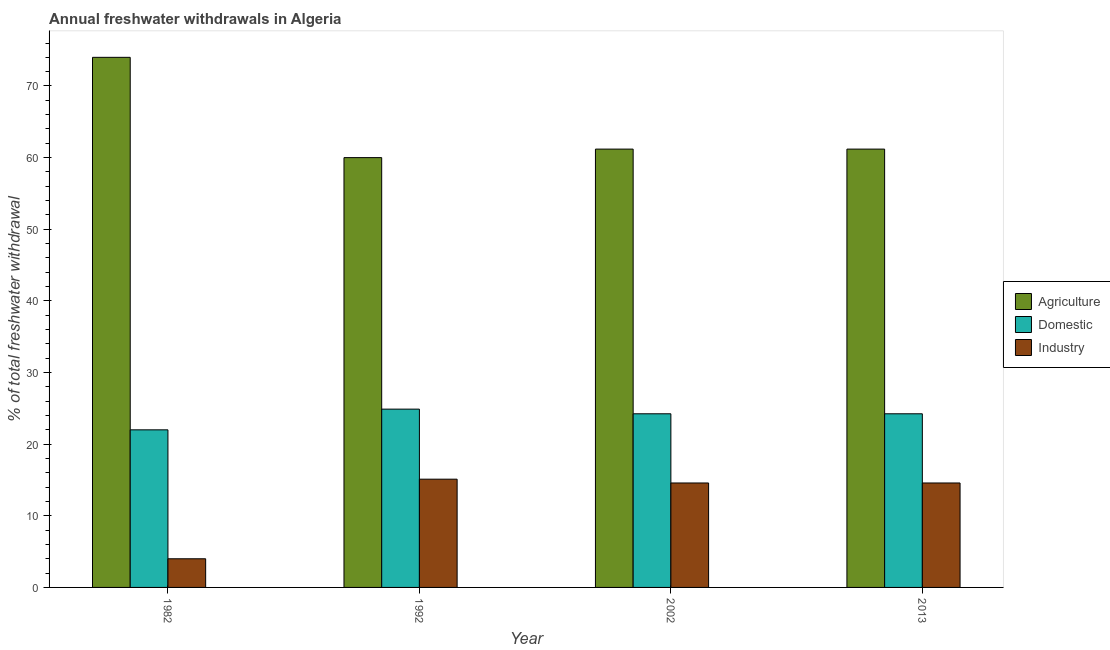How many different coloured bars are there?
Your answer should be very brief. 3. Are the number of bars per tick equal to the number of legend labels?
Your response must be concise. Yes. What is the label of the 4th group of bars from the left?
Make the answer very short. 2013. In how many cases, is the number of bars for a given year not equal to the number of legend labels?
Provide a short and direct response. 0. What is the percentage of freshwater withdrawal for domestic purposes in 2013?
Your response must be concise. 24.24. Across all years, what is the maximum percentage of freshwater withdrawal for industry?
Make the answer very short. 15.11. What is the total percentage of freshwater withdrawal for industry in the graph?
Your answer should be very brief. 48.27. What is the difference between the percentage of freshwater withdrawal for industry in 1982 and that in 2013?
Ensure brevity in your answer.  -10.58. What is the average percentage of freshwater withdrawal for agriculture per year?
Make the answer very short. 64.09. In the year 2002, what is the difference between the percentage of freshwater withdrawal for agriculture and percentage of freshwater withdrawal for domestic purposes?
Provide a short and direct response. 0. In how many years, is the percentage of freshwater withdrawal for industry greater than 70 %?
Offer a very short reply. 0. What is the ratio of the percentage of freshwater withdrawal for agriculture in 1982 to that in 2002?
Provide a short and direct response. 1.21. Is the difference between the percentage of freshwater withdrawal for agriculture in 1992 and 2013 greater than the difference between the percentage of freshwater withdrawal for industry in 1992 and 2013?
Offer a very short reply. No. What is the difference between the highest and the second highest percentage of freshwater withdrawal for agriculture?
Your answer should be very brief. 12.81. What is the difference between the highest and the lowest percentage of freshwater withdrawal for domestic purposes?
Ensure brevity in your answer.  2.89. Is the sum of the percentage of freshwater withdrawal for agriculture in 1992 and 2002 greater than the maximum percentage of freshwater withdrawal for industry across all years?
Give a very brief answer. Yes. What does the 3rd bar from the left in 2013 represents?
Offer a terse response. Industry. What does the 3rd bar from the right in 2002 represents?
Ensure brevity in your answer.  Agriculture. Is it the case that in every year, the sum of the percentage of freshwater withdrawal for agriculture and percentage of freshwater withdrawal for domestic purposes is greater than the percentage of freshwater withdrawal for industry?
Offer a terse response. Yes. How many bars are there?
Provide a short and direct response. 12. Are all the bars in the graph horizontal?
Keep it short and to the point. No. How many years are there in the graph?
Your response must be concise. 4. What is the difference between two consecutive major ticks on the Y-axis?
Your answer should be compact. 10. Are the values on the major ticks of Y-axis written in scientific E-notation?
Provide a short and direct response. No. Where does the legend appear in the graph?
Provide a succinct answer. Center right. How many legend labels are there?
Your response must be concise. 3. What is the title of the graph?
Offer a terse response. Annual freshwater withdrawals in Algeria. Does "Food" appear as one of the legend labels in the graph?
Make the answer very short. No. What is the label or title of the Y-axis?
Provide a succinct answer. % of total freshwater withdrawal. What is the % of total freshwater withdrawal of Agriculture in 1982?
Provide a succinct answer. 74. What is the % of total freshwater withdrawal of Agriculture in 1992?
Offer a very short reply. 60. What is the % of total freshwater withdrawal in Domestic in 1992?
Provide a succinct answer. 24.89. What is the % of total freshwater withdrawal in Industry in 1992?
Provide a succinct answer. 15.11. What is the % of total freshwater withdrawal in Agriculture in 2002?
Your response must be concise. 61.19. What is the % of total freshwater withdrawal in Domestic in 2002?
Your answer should be compact. 24.24. What is the % of total freshwater withdrawal of Industry in 2002?
Ensure brevity in your answer.  14.58. What is the % of total freshwater withdrawal in Agriculture in 2013?
Your answer should be compact. 61.19. What is the % of total freshwater withdrawal of Domestic in 2013?
Provide a succinct answer. 24.24. What is the % of total freshwater withdrawal in Industry in 2013?
Give a very brief answer. 14.58. Across all years, what is the maximum % of total freshwater withdrawal of Agriculture?
Offer a very short reply. 74. Across all years, what is the maximum % of total freshwater withdrawal in Domestic?
Your answer should be very brief. 24.89. Across all years, what is the maximum % of total freshwater withdrawal in Industry?
Your response must be concise. 15.11. Across all years, what is the minimum % of total freshwater withdrawal of Agriculture?
Keep it short and to the point. 60. Across all years, what is the minimum % of total freshwater withdrawal of Domestic?
Provide a succinct answer. 22. What is the total % of total freshwater withdrawal in Agriculture in the graph?
Provide a short and direct response. 256.38. What is the total % of total freshwater withdrawal in Domestic in the graph?
Give a very brief answer. 95.37. What is the total % of total freshwater withdrawal of Industry in the graph?
Offer a very short reply. 48.27. What is the difference between the % of total freshwater withdrawal in Domestic in 1982 and that in 1992?
Offer a very short reply. -2.89. What is the difference between the % of total freshwater withdrawal in Industry in 1982 and that in 1992?
Your response must be concise. -11.11. What is the difference between the % of total freshwater withdrawal of Agriculture in 1982 and that in 2002?
Offer a terse response. 12.81. What is the difference between the % of total freshwater withdrawal in Domestic in 1982 and that in 2002?
Make the answer very short. -2.24. What is the difference between the % of total freshwater withdrawal of Industry in 1982 and that in 2002?
Provide a short and direct response. -10.58. What is the difference between the % of total freshwater withdrawal in Agriculture in 1982 and that in 2013?
Provide a short and direct response. 12.81. What is the difference between the % of total freshwater withdrawal of Domestic in 1982 and that in 2013?
Your answer should be compact. -2.24. What is the difference between the % of total freshwater withdrawal in Industry in 1982 and that in 2013?
Offer a very short reply. -10.58. What is the difference between the % of total freshwater withdrawal in Agriculture in 1992 and that in 2002?
Provide a short and direct response. -1.19. What is the difference between the % of total freshwater withdrawal in Domestic in 1992 and that in 2002?
Your answer should be compact. 0.65. What is the difference between the % of total freshwater withdrawal of Industry in 1992 and that in 2002?
Offer a terse response. 0.53. What is the difference between the % of total freshwater withdrawal in Agriculture in 1992 and that in 2013?
Give a very brief answer. -1.19. What is the difference between the % of total freshwater withdrawal of Domestic in 1992 and that in 2013?
Provide a short and direct response. 0.65. What is the difference between the % of total freshwater withdrawal of Industry in 1992 and that in 2013?
Your answer should be very brief. 0.53. What is the difference between the % of total freshwater withdrawal in Agriculture in 2002 and that in 2013?
Your answer should be compact. 0. What is the difference between the % of total freshwater withdrawal of Domestic in 2002 and that in 2013?
Give a very brief answer. 0. What is the difference between the % of total freshwater withdrawal in Industry in 2002 and that in 2013?
Keep it short and to the point. 0. What is the difference between the % of total freshwater withdrawal in Agriculture in 1982 and the % of total freshwater withdrawal in Domestic in 1992?
Your response must be concise. 49.11. What is the difference between the % of total freshwater withdrawal in Agriculture in 1982 and the % of total freshwater withdrawal in Industry in 1992?
Offer a very short reply. 58.89. What is the difference between the % of total freshwater withdrawal of Domestic in 1982 and the % of total freshwater withdrawal of Industry in 1992?
Your response must be concise. 6.89. What is the difference between the % of total freshwater withdrawal of Agriculture in 1982 and the % of total freshwater withdrawal of Domestic in 2002?
Your answer should be compact. 49.76. What is the difference between the % of total freshwater withdrawal of Agriculture in 1982 and the % of total freshwater withdrawal of Industry in 2002?
Keep it short and to the point. 59.42. What is the difference between the % of total freshwater withdrawal of Domestic in 1982 and the % of total freshwater withdrawal of Industry in 2002?
Your answer should be very brief. 7.42. What is the difference between the % of total freshwater withdrawal of Agriculture in 1982 and the % of total freshwater withdrawal of Domestic in 2013?
Make the answer very short. 49.76. What is the difference between the % of total freshwater withdrawal in Agriculture in 1982 and the % of total freshwater withdrawal in Industry in 2013?
Give a very brief answer. 59.42. What is the difference between the % of total freshwater withdrawal in Domestic in 1982 and the % of total freshwater withdrawal in Industry in 2013?
Provide a short and direct response. 7.42. What is the difference between the % of total freshwater withdrawal of Agriculture in 1992 and the % of total freshwater withdrawal of Domestic in 2002?
Make the answer very short. 35.76. What is the difference between the % of total freshwater withdrawal of Agriculture in 1992 and the % of total freshwater withdrawal of Industry in 2002?
Your answer should be compact. 45.42. What is the difference between the % of total freshwater withdrawal of Domestic in 1992 and the % of total freshwater withdrawal of Industry in 2002?
Your answer should be compact. 10.31. What is the difference between the % of total freshwater withdrawal of Agriculture in 1992 and the % of total freshwater withdrawal of Domestic in 2013?
Your answer should be compact. 35.76. What is the difference between the % of total freshwater withdrawal in Agriculture in 1992 and the % of total freshwater withdrawal in Industry in 2013?
Your response must be concise. 45.42. What is the difference between the % of total freshwater withdrawal of Domestic in 1992 and the % of total freshwater withdrawal of Industry in 2013?
Offer a terse response. 10.31. What is the difference between the % of total freshwater withdrawal of Agriculture in 2002 and the % of total freshwater withdrawal of Domestic in 2013?
Offer a very short reply. 36.95. What is the difference between the % of total freshwater withdrawal of Agriculture in 2002 and the % of total freshwater withdrawal of Industry in 2013?
Provide a short and direct response. 46.61. What is the difference between the % of total freshwater withdrawal of Domestic in 2002 and the % of total freshwater withdrawal of Industry in 2013?
Your response must be concise. 9.66. What is the average % of total freshwater withdrawal in Agriculture per year?
Make the answer very short. 64.09. What is the average % of total freshwater withdrawal of Domestic per year?
Your answer should be compact. 23.84. What is the average % of total freshwater withdrawal of Industry per year?
Make the answer very short. 12.07. In the year 1982, what is the difference between the % of total freshwater withdrawal in Agriculture and % of total freshwater withdrawal in Domestic?
Offer a terse response. 52. In the year 1982, what is the difference between the % of total freshwater withdrawal in Agriculture and % of total freshwater withdrawal in Industry?
Your response must be concise. 70. In the year 1982, what is the difference between the % of total freshwater withdrawal in Domestic and % of total freshwater withdrawal in Industry?
Your answer should be very brief. 18. In the year 1992, what is the difference between the % of total freshwater withdrawal of Agriculture and % of total freshwater withdrawal of Domestic?
Provide a short and direct response. 35.11. In the year 1992, what is the difference between the % of total freshwater withdrawal of Agriculture and % of total freshwater withdrawal of Industry?
Provide a short and direct response. 44.89. In the year 1992, what is the difference between the % of total freshwater withdrawal in Domestic and % of total freshwater withdrawal in Industry?
Offer a very short reply. 9.78. In the year 2002, what is the difference between the % of total freshwater withdrawal in Agriculture and % of total freshwater withdrawal in Domestic?
Make the answer very short. 36.95. In the year 2002, what is the difference between the % of total freshwater withdrawal of Agriculture and % of total freshwater withdrawal of Industry?
Offer a very short reply. 46.61. In the year 2002, what is the difference between the % of total freshwater withdrawal of Domestic and % of total freshwater withdrawal of Industry?
Ensure brevity in your answer.  9.66. In the year 2013, what is the difference between the % of total freshwater withdrawal of Agriculture and % of total freshwater withdrawal of Domestic?
Ensure brevity in your answer.  36.95. In the year 2013, what is the difference between the % of total freshwater withdrawal in Agriculture and % of total freshwater withdrawal in Industry?
Ensure brevity in your answer.  46.61. In the year 2013, what is the difference between the % of total freshwater withdrawal of Domestic and % of total freshwater withdrawal of Industry?
Give a very brief answer. 9.66. What is the ratio of the % of total freshwater withdrawal in Agriculture in 1982 to that in 1992?
Offer a terse response. 1.23. What is the ratio of the % of total freshwater withdrawal in Domestic in 1982 to that in 1992?
Provide a short and direct response. 0.88. What is the ratio of the % of total freshwater withdrawal of Industry in 1982 to that in 1992?
Your answer should be compact. 0.26. What is the ratio of the % of total freshwater withdrawal of Agriculture in 1982 to that in 2002?
Keep it short and to the point. 1.21. What is the ratio of the % of total freshwater withdrawal in Domestic in 1982 to that in 2002?
Offer a very short reply. 0.91. What is the ratio of the % of total freshwater withdrawal of Industry in 1982 to that in 2002?
Provide a succinct answer. 0.27. What is the ratio of the % of total freshwater withdrawal of Agriculture in 1982 to that in 2013?
Your answer should be very brief. 1.21. What is the ratio of the % of total freshwater withdrawal of Domestic in 1982 to that in 2013?
Offer a terse response. 0.91. What is the ratio of the % of total freshwater withdrawal in Industry in 1982 to that in 2013?
Your response must be concise. 0.27. What is the ratio of the % of total freshwater withdrawal of Agriculture in 1992 to that in 2002?
Your response must be concise. 0.98. What is the ratio of the % of total freshwater withdrawal in Domestic in 1992 to that in 2002?
Provide a succinct answer. 1.03. What is the ratio of the % of total freshwater withdrawal in Industry in 1992 to that in 2002?
Give a very brief answer. 1.04. What is the ratio of the % of total freshwater withdrawal in Agriculture in 1992 to that in 2013?
Ensure brevity in your answer.  0.98. What is the ratio of the % of total freshwater withdrawal in Domestic in 1992 to that in 2013?
Provide a short and direct response. 1.03. What is the ratio of the % of total freshwater withdrawal in Industry in 1992 to that in 2013?
Offer a very short reply. 1.04. What is the ratio of the % of total freshwater withdrawal of Agriculture in 2002 to that in 2013?
Make the answer very short. 1. What is the ratio of the % of total freshwater withdrawal in Industry in 2002 to that in 2013?
Your answer should be very brief. 1. What is the difference between the highest and the second highest % of total freshwater withdrawal in Agriculture?
Your answer should be compact. 12.81. What is the difference between the highest and the second highest % of total freshwater withdrawal of Domestic?
Your answer should be compact. 0.65. What is the difference between the highest and the second highest % of total freshwater withdrawal in Industry?
Offer a terse response. 0.53. What is the difference between the highest and the lowest % of total freshwater withdrawal of Domestic?
Offer a terse response. 2.89. What is the difference between the highest and the lowest % of total freshwater withdrawal in Industry?
Offer a very short reply. 11.11. 